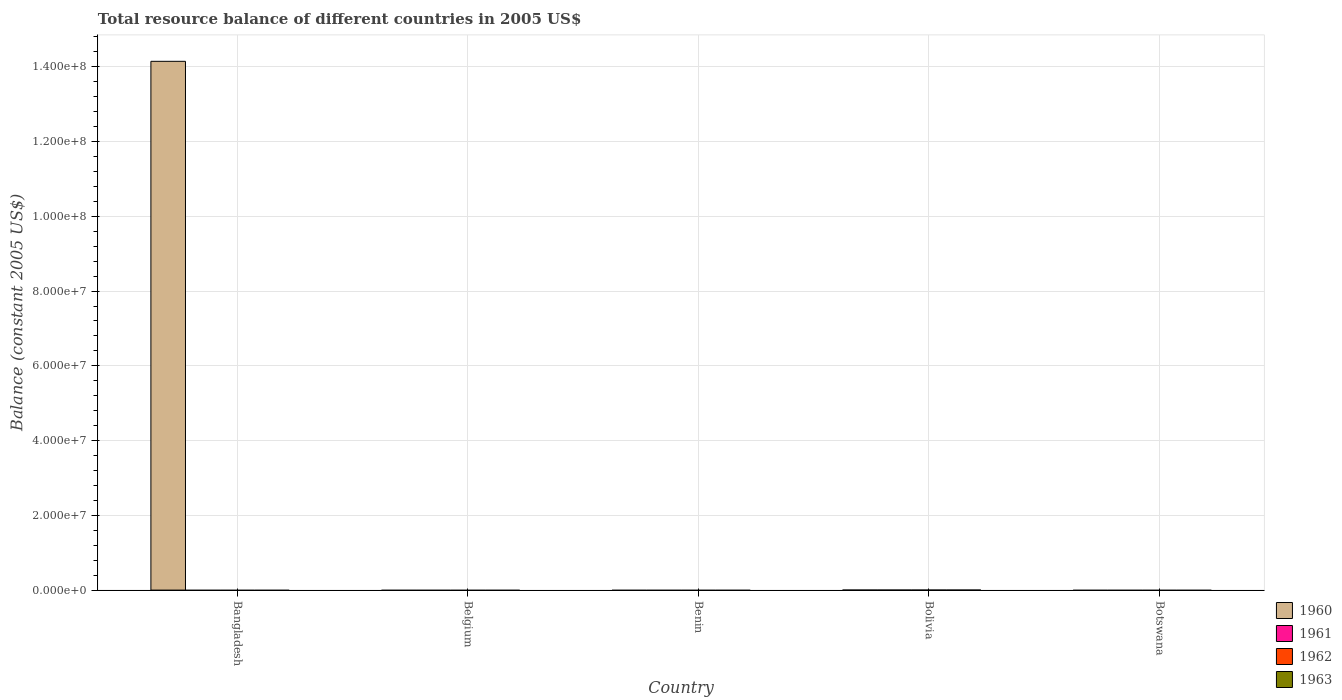How many different coloured bars are there?
Offer a terse response. 1. Are the number of bars per tick equal to the number of legend labels?
Your answer should be compact. No. Are the number of bars on each tick of the X-axis equal?
Offer a terse response. No. How many bars are there on the 1st tick from the right?
Offer a terse response. 0. What is the label of the 2nd group of bars from the left?
Ensure brevity in your answer.  Belgium. Across all countries, what is the maximum total resource balance in 1960?
Make the answer very short. 1.41e+08. Across all countries, what is the minimum total resource balance in 1963?
Your answer should be very brief. 0. In which country was the total resource balance in 1960 maximum?
Ensure brevity in your answer.  Bangladesh. In how many countries, is the total resource balance in 1962 greater than 136000000 US$?
Your answer should be very brief. 0. What is the difference between the highest and the lowest total resource balance in 1960?
Provide a succinct answer. 1.41e+08. Is it the case that in every country, the sum of the total resource balance in 1960 and total resource balance in 1962 is greater than the total resource balance in 1963?
Offer a terse response. No. How many bars are there?
Make the answer very short. 1. How many countries are there in the graph?
Give a very brief answer. 5. What is the difference between two consecutive major ticks on the Y-axis?
Provide a succinct answer. 2.00e+07. Are the values on the major ticks of Y-axis written in scientific E-notation?
Ensure brevity in your answer.  Yes. Does the graph contain grids?
Your answer should be very brief. Yes. Where does the legend appear in the graph?
Your answer should be very brief. Bottom right. How are the legend labels stacked?
Provide a short and direct response. Vertical. What is the title of the graph?
Offer a terse response. Total resource balance of different countries in 2005 US$. Does "1995" appear as one of the legend labels in the graph?
Provide a succinct answer. No. What is the label or title of the X-axis?
Provide a succinct answer. Country. What is the label or title of the Y-axis?
Provide a succinct answer. Balance (constant 2005 US$). What is the Balance (constant 2005 US$) of 1960 in Bangladesh?
Provide a short and direct response. 1.41e+08. What is the Balance (constant 2005 US$) of 1961 in Bangladesh?
Give a very brief answer. 0. What is the Balance (constant 2005 US$) in 1963 in Bangladesh?
Offer a very short reply. 0. What is the Balance (constant 2005 US$) in 1960 in Belgium?
Provide a succinct answer. 0. What is the Balance (constant 2005 US$) in 1962 in Belgium?
Give a very brief answer. 0. What is the Balance (constant 2005 US$) of 1960 in Benin?
Offer a very short reply. 0. What is the Balance (constant 2005 US$) in 1961 in Benin?
Offer a very short reply. 0. What is the Balance (constant 2005 US$) of 1962 in Benin?
Provide a short and direct response. 0. What is the Balance (constant 2005 US$) of 1963 in Benin?
Make the answer very short. 0. What is the Balance (constant 2005 US$) of 1962 in Bolivia?
Keep it short and to the point. 0. What is the Balance (constant 2005 US$) in 1963 in Bolivia?
Ensure brevity in your answer.  0. Across all countries, what is the maximum Balance (constant 2005 US$) of 1960?
Your answer should be very brief. 1.41e+08. What is the total Balance (constant 2005 US$) of 1960 in the graph?
Offer a terse response. 1.41e+08. What is the total Balance (constant 2005 US$) in 1963 in the graph?
Your answer should be compact. 0. What is the average Balance (constant 2005 US$) of 1960 per country?
Give a very brief answer. 2.83e+07. What is the average Balance (constant 2005 US$) of 1961 per country?
Offer a terse response. 0. What is the average Balance (constant 2005 US$) in 1963 per country?
Offer a very short reply. 0. What is the difference between the highest and the lowest Balance (constant 2005 US$) in 1960?
Make the answer very short. 1.41e+08. 